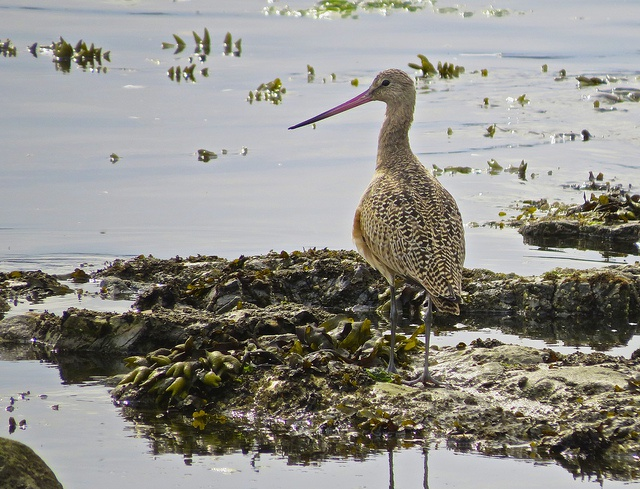Describe the objects in this image and their specific colors. I can see a bird in darkgray, gray, tan, and black tones in this image. 